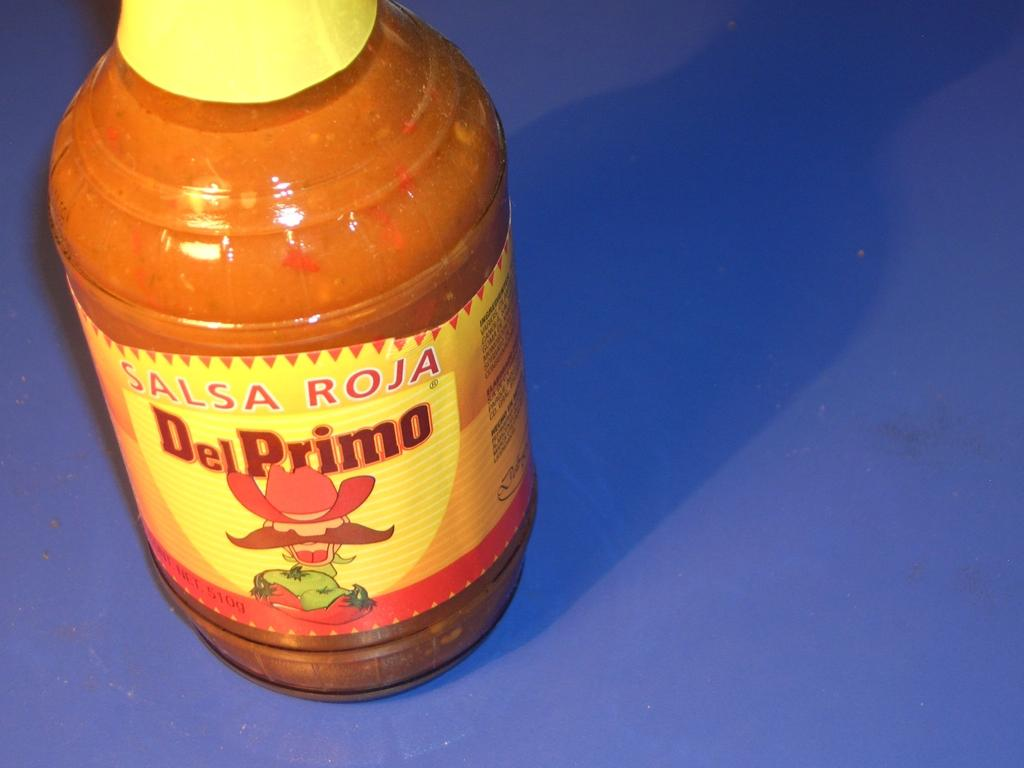<image>
Share a concise interpretation of the image provided. A jar of Salsa Roja Del Primo sits on a blue surface. 